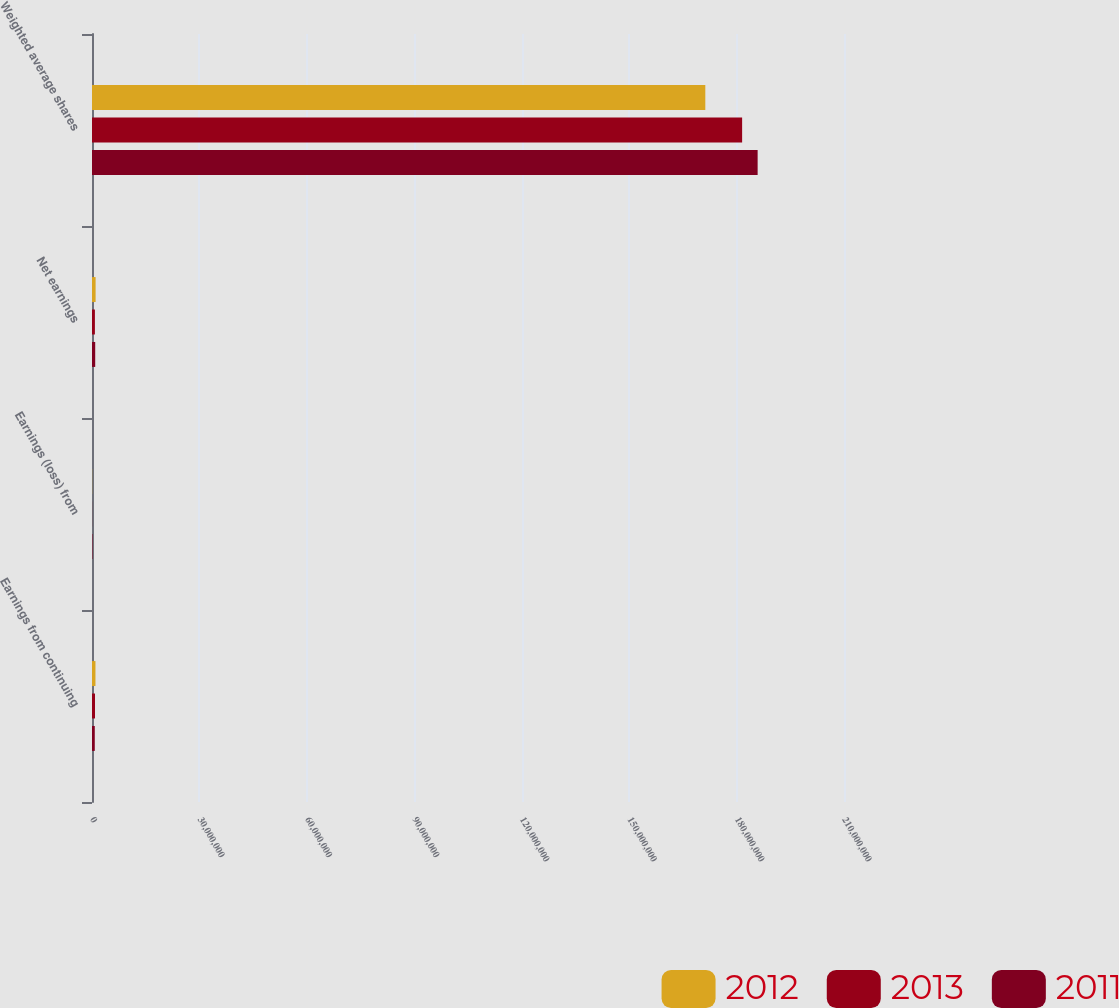Convert chart. <chart><loc_0><loc_0><loc_500><loc_500><stacked_bar_chart><ecel><fcel>Earnings from continuing<fcel>Earnings (loss) from<fcel>Net earnings<fcel>Weighted average shares<nl><fcel>2012<fcel>965805<fcel>37324<fcel>1.00313e+06<fcel>1.71271e+08<nl><fcel>2013<fcel>833119<fcel>22049<fcel>811070<fcel>1.81551e+08<nl><fcel>2011<fcel>773186<fcel>122057<fcel>895243<fcel>1.85882e+08<nl></chart> 